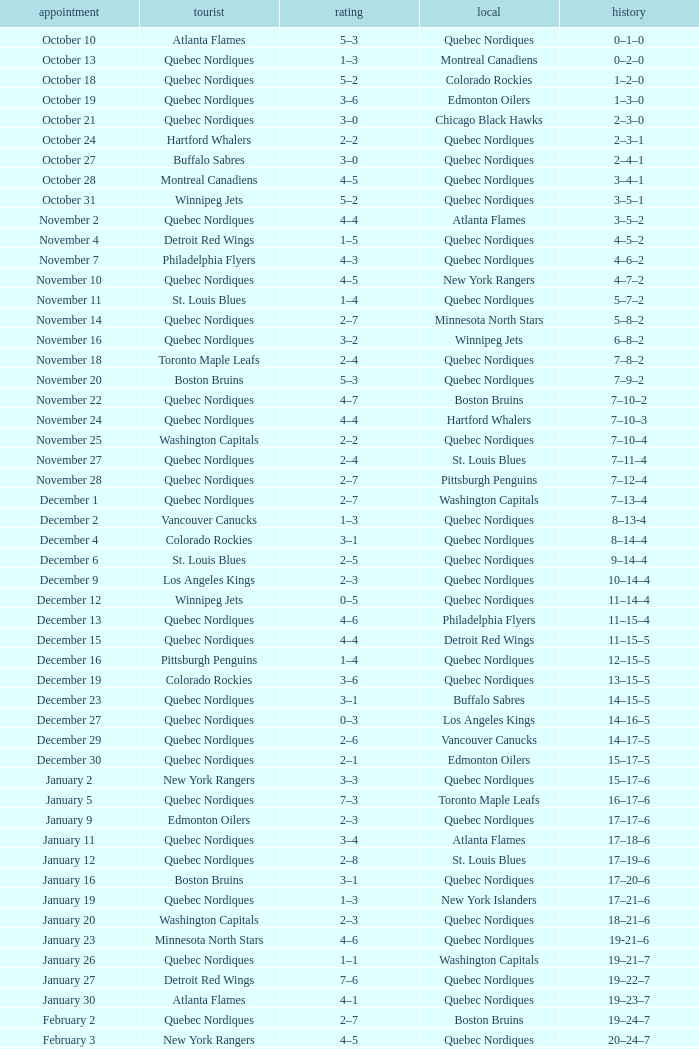Which Home has a Date of april 1? Quebec Nordiques. 